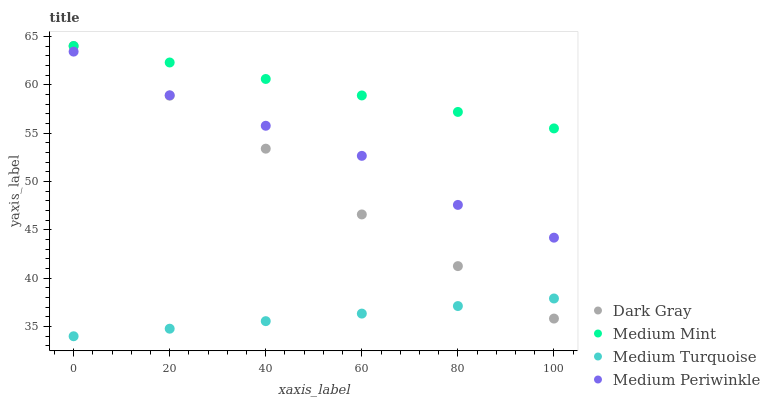Does Medium Turquoise have the minimum area under the curve?
Answer yes or no. Yes. Does Medium Mint have the maximum area under the curve?
Answer yes or no. Yes. Does Medium Periwinkle have the minimum area under the curve?
Answer yes or no. No. Does Medium Periwinkle have the maximum area under the curve?
Answer yes or no. No. Is Medium Mint the smoothest?
Answer yes or no. Yes. Is Medium Periwinkle the roughest?
Answer yes or no. Yes. Is Medium Periwinkle the smoothest?
Answer yes or no. No. Is Medium Mint the roughest?
Answer yes or no. No. Does Medium Turquoise have the lowest value?
Answer yes or no. Yes. Does Medium Periwinkle have the lowest value?
Answer yes or no. No. Does Medium Mint have the highest value?
Answer yes or no. Yes. Does Medium Periwinkle have the highest value?
Answer yes or no. No. Is Medium Periwinkle less than Medium Mint?
Answer yes or no. Yes. Is Medium Mint greater than Medium Turquoise?
Answer yes or no. Yes. Does Medium Mint intersect Dark Gray?
Answer yes or no. Yes. Is Medium Mint less than Dark Gray?
Answer yes or no. No. Is Medium Mint greater than Dark Gray?
Answer yes or no. No. Does Medium Periwinkle intersect Medium Mint?
Answer yes or no. No. 